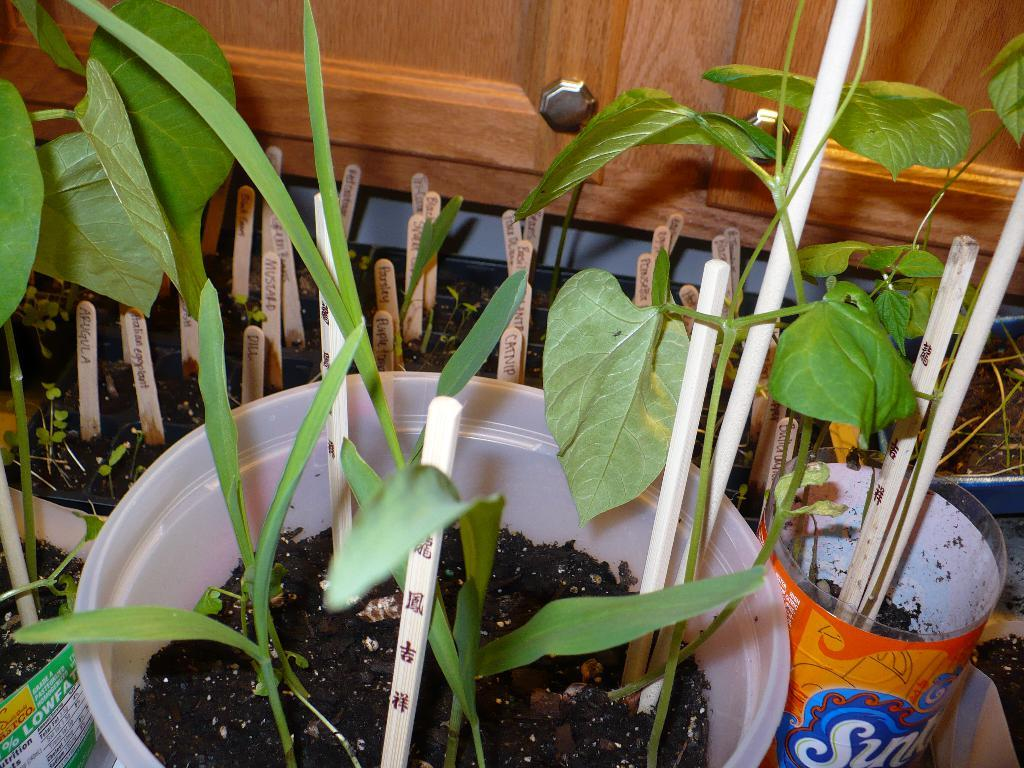What type of living organisms can be seen in the image? Plants can be seen in the image. How are the plants arranged or organized in the image? The plants are planted in small tubs. What additional objects can be seen among the plants in the image? There are wooden sticks inserted into the soil between the plants. How many pigs are visible in the image? There are no pigs present in the image; it features plants in small tubs with wooden sticks inserted into the soil. What type of train can be seen passing by in the image? There is no train present in the image; it focuses on plants in small tubs with wooden sticks inserted into the soil. 